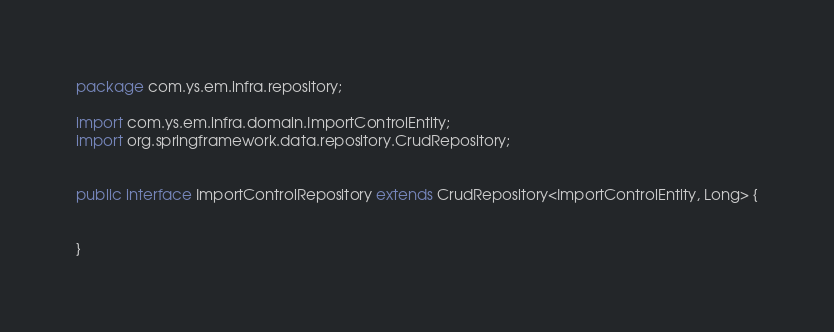Convert code to text. <code><loc_0><loc_0><loc_500><loc_500><_Java_>package com.ys.em.infra.repository;

import com.ys.em.infra.domain.ImportControlEntity;
import org.springframework.data.repository.CrudRepository;


public interface ImportControlRepository extends CrudRepository<ImportControlEntity, Long> {


}</code> 